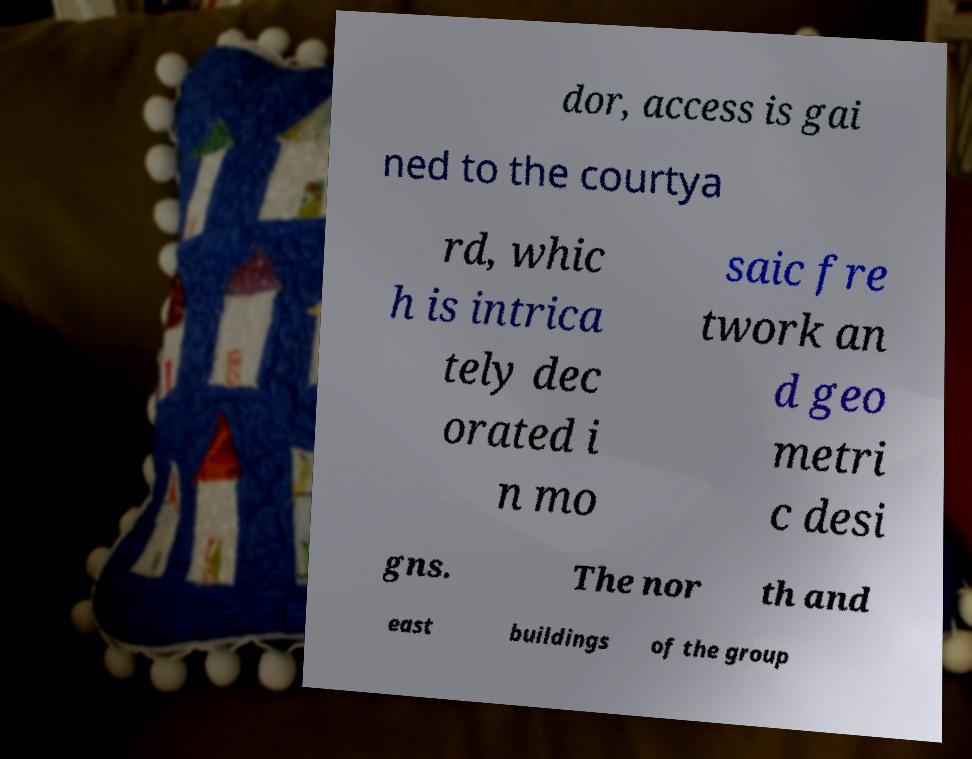Can you read and provide the text displayed in the image?This photo seems to have some interesting text. Can you extract and type it out for me? dor, access is gai ned to the courtya rd, whic h is intrica tely dec orated i n mo saic fre twork an d geo metri c desi gns. The nor th and east buildings of the group 